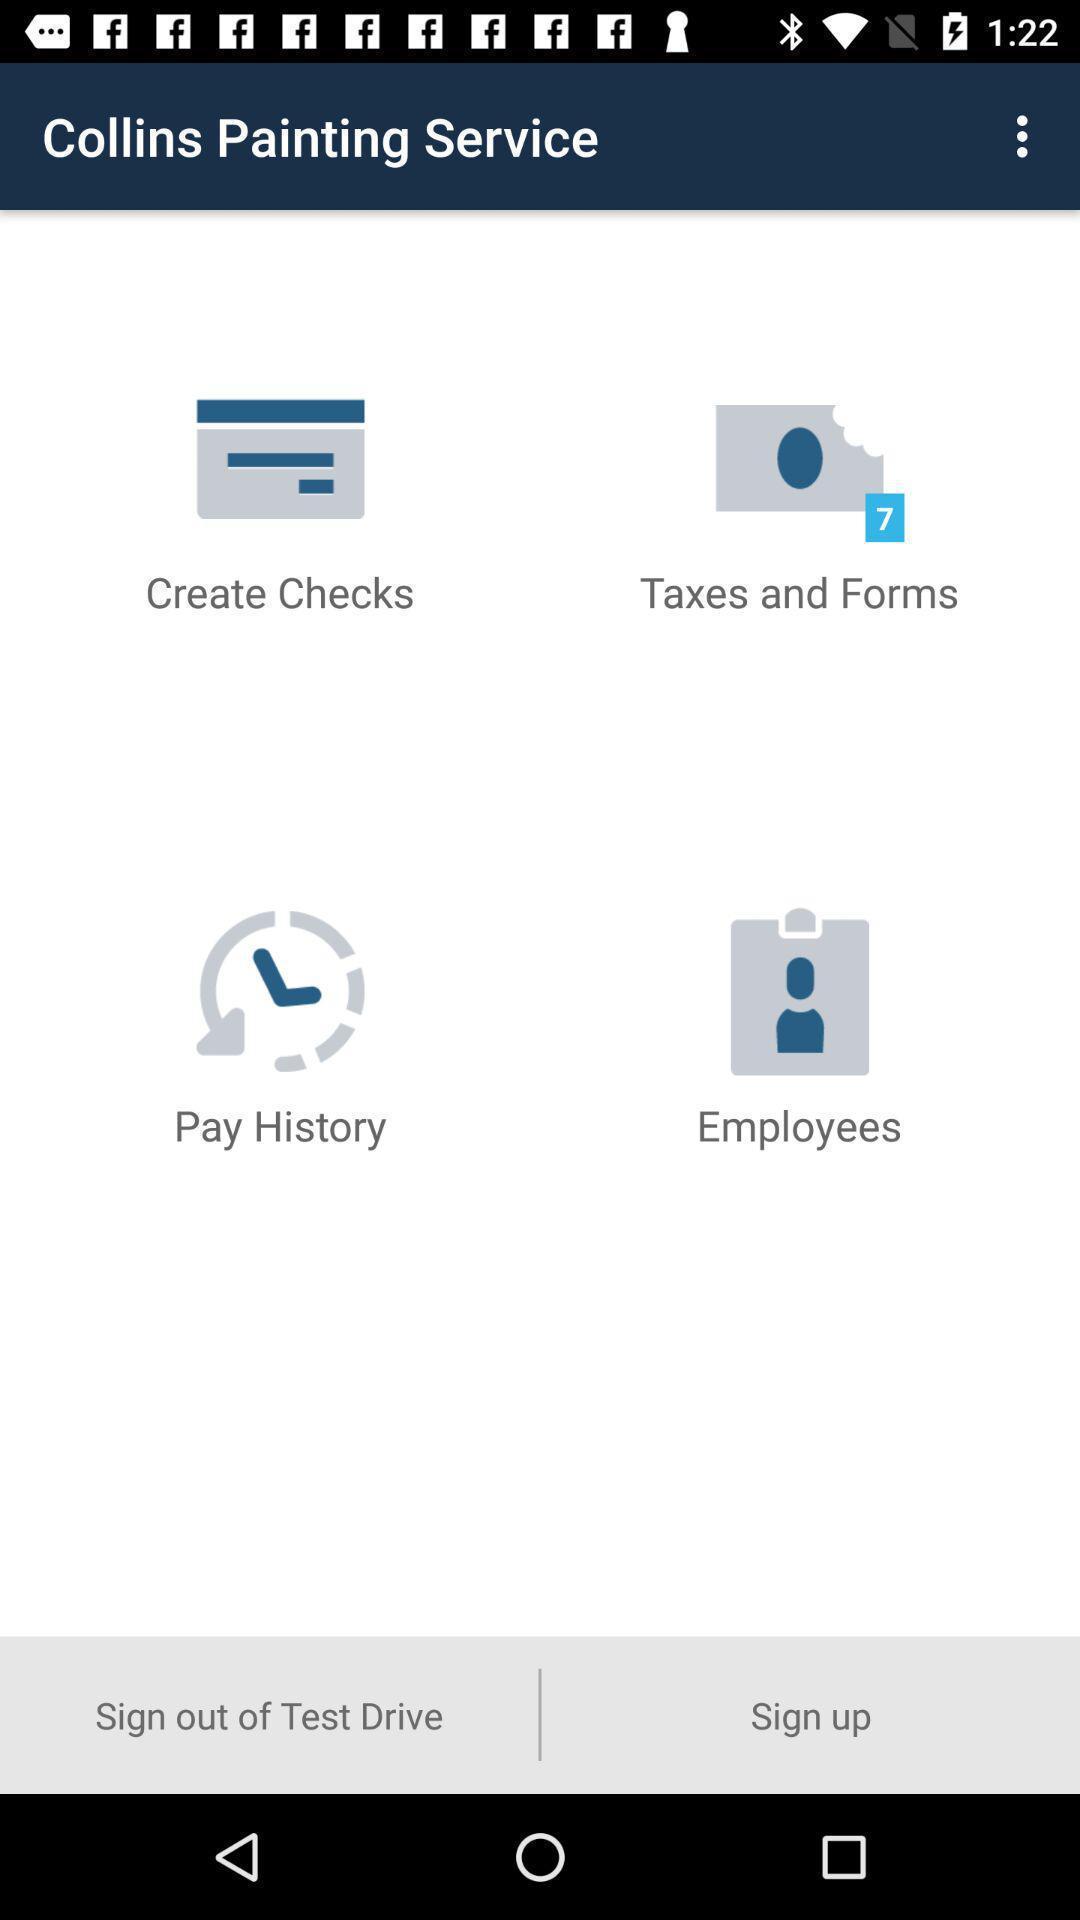Provide a description of this screenshot. Sign-up page and other different options displayed. 